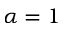Convert formula to latex. <formula><loc_0><loc_0><loc_500><loc_500>\alpha = 1</formula> 